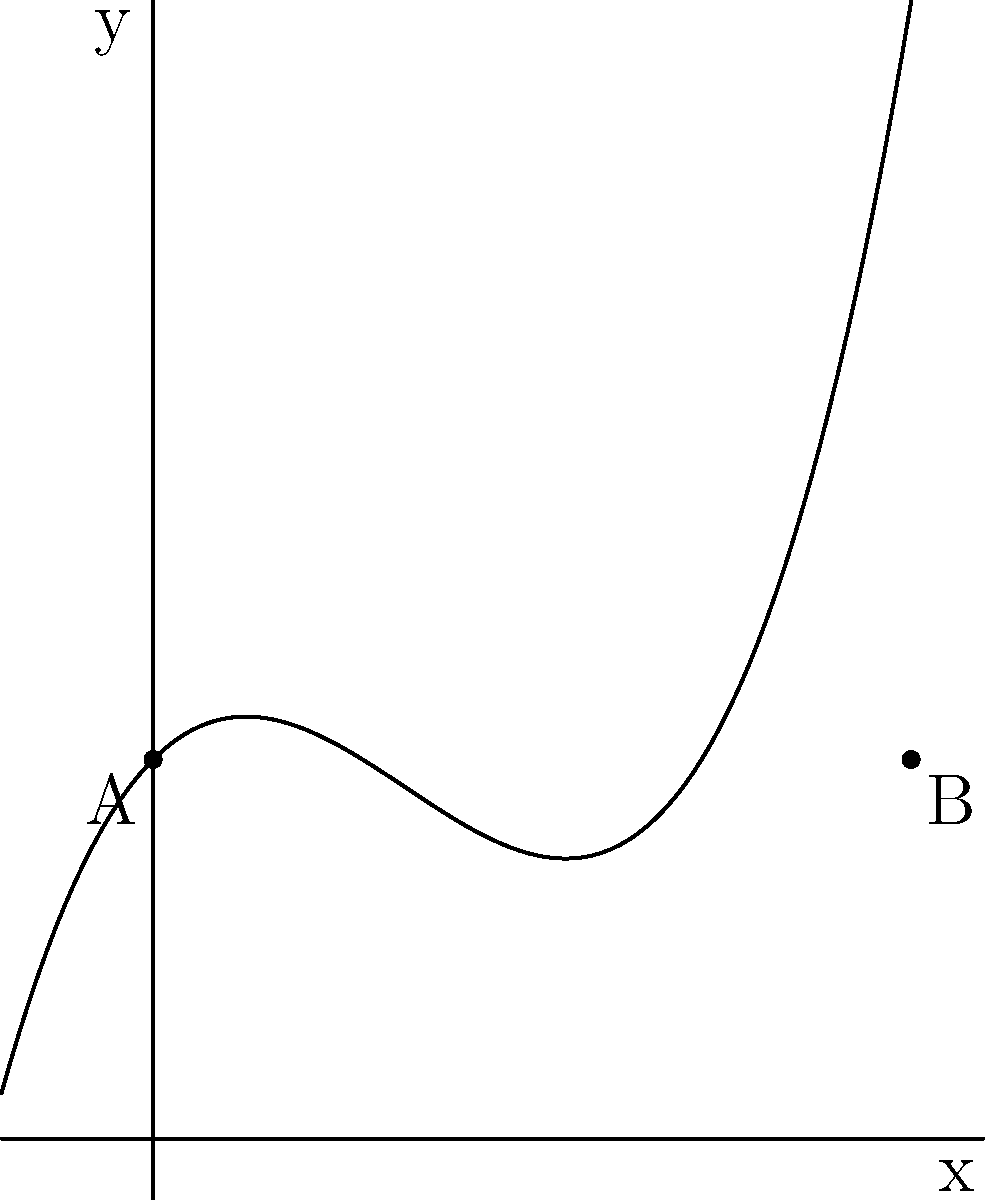A family-friendly roller coaster track is designed using the polynomial function $f(x) = 0.05x^3 - 0.5x^2 + x + 5$, where $x$ represents the horizontal distance and $f(x)$ represents the height of the track (both in meters). The track starts at point A (0, 5) and ends at point B (10, 5). What is the maximum height of the roller coaster track, rounded to the nearest tenth of a meter? To find the maximum height of the roller coaster track, we need to follow these steps:

1) The maximum height occurs at the highest point of the curve, where the derivative of the function equals zero.

2) Let's find the derivative of $f(x)$:
   $f'(x) = 0.15x^2 - x + 1$

3) Set $f'(x) = 0$ and solve for $x$:
   $0.15x^2 - x + 1 = 0$

4) This is a quadratic equation. We can solve it using the quadratic formula:
   $x = \frac{-b \pm \sqrt{b^2 - 4ac}}{2a}$

   Where $a = 0.15$, $b = -1$, and $c = 1$

5) Plugging in these values:
   $x = \frac{1 \pm \sqrt{1 - 4(0.15)(1)}}{2(0.15)} = \frac{1 \pm \sqrt{0.4}}{0.3}$

6) This gives us two solutions:
   $x_1 \approx 5.39$ and $x_2 \approx 1.28$

7) We need to check which of these gives the higher $y$ value:
   $f(5.39) \approx 7.72$
   $f(1.28) \approx 5.83$

8) The maximum height is at $x \approx 5.39$, where $f(5.39) \approx 7.72$

9) Rounding to the nearest tenth: 7.7 meters
Answer: 7.7 meters 